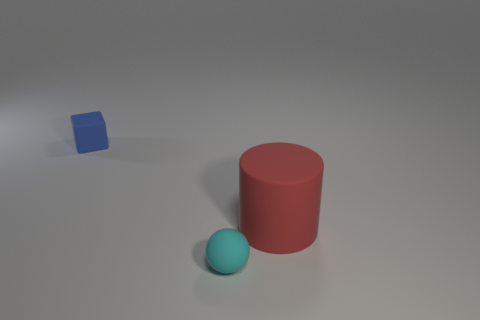Does the tiny thing that is to the right of the tiny matte block have the same material as the red cylinder?
Offer a very short reply. Yes. Do the large red thing and the tiny blue matte thing have the same shape?
Make the answer very short. No. What number of objects are either things in front of the red matte object or yellow objects?
Make the answer very short. 1. There is a red cylinder that is made of the same material as the cyan ball; what is its size?
Offer a terse response. Large. What number of rubber spheres are the same color as the large thing?
Ensure brevity in your answer.  0. How many small things are either yellow shiny cubes or red rubber cylinders?
Offer a terse response. 0. Are there any big spheres made of the same material as the cylinder?
Ensure brevity in your answer.  No. What is the material of the thing on the right side of the matte sphere?
Your response must be concise. Rubber. There is a small thing to the left of the cyan matte object; is it the same color as the matte thing in front of the red matte object?
Provide a short and direct response. No. What color is the matte cube that is the same size as the cyan rubber ball?
Give a very brief answer. Blue. 